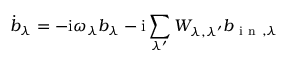<formula> <loc_0><loc_0><loc_500><loc_500>\dot { b } _ { \lambda } = - i \omega _ { \lambda } b _ { \lambda } - i \sum _ { \lambda ^ { \prime } } W _ { \lambda , \lambda ^ { \prime } } b _ { i n , \lambda }</formula> 